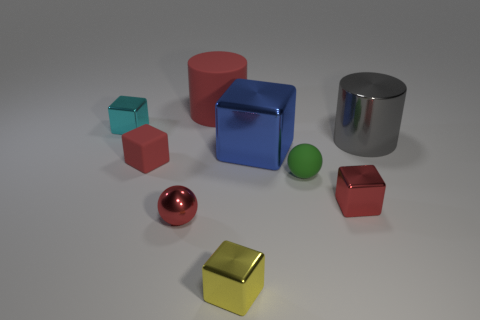Subtract all cyan blocks. How many blocks are left? 4 Subtract all rubber cubes. How many cubes are left? 4 Subtract all brown blocks. Subtract all blue spheres. How many blocks are left? 5 Subtract all spheres. How many objects are left? 7 Add 4 gray shiny cylinders. How many gray shiny cylinders exist? 5 Subtract 0 yellow spheres. How many objects are left? 9 Subtract all big gray cylinders. Subtract all green objects. How many objects are left? 7 Add 8 large blue things. How many large blue things are left? 9 